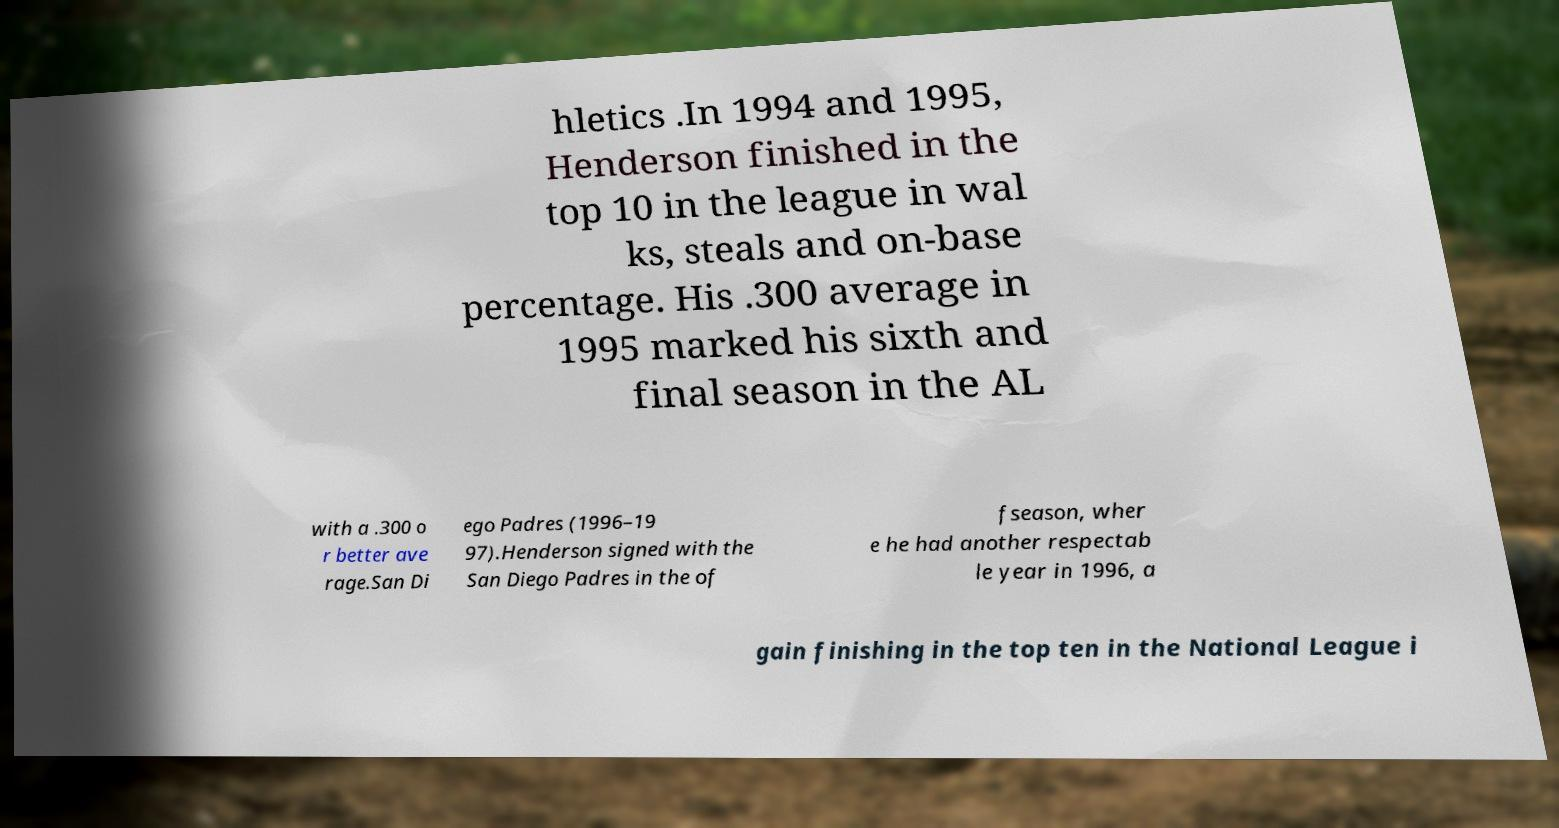Can you accurately transcribe the text from the provided image for me? hletics .In 1994 and 1995, Henderson finished in the top 10 in the league in wal ks, steals and on-base percentage. His .300 average in 1995 marked his sixth and final season in the AL with a .300 o r better ave rage.San Di ego Padres (1996–19 97).Henderson signed with the San Diego Padres in the of fseason, wher e he had another respectab le year in 1996, a gain finishing in the top ten in the National League i 